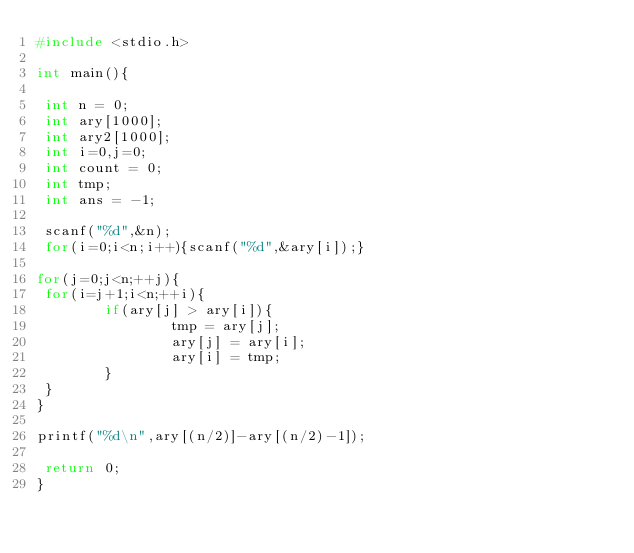Convert code to text. <code><loc_0><loc_0><loc_500><loc_500><_C_>#include <stdio.h>

int main(){

 int n = 0;
 int ary[1000];
 int ary2[1000];
 int i=0,j=0;
 int count = 0;
 int tmp;
 int ans = -1;

 scanf("%d",&n);
 for(i=0;i<n;i++){scanf("%d",&ary[i]);}

for(j=0;j<n;++j){
 for(i=j+1;i<n;++i){
        if(ary[j] > ary[i]){
                tmp = ary[j];
                ary[j] = ary[i];
                ary[i] = tmp;
        }
 }
}

printf("%d\n",ary[(n/2)]-ary[(n/2)-1]);

 return 0;
}
</code> 